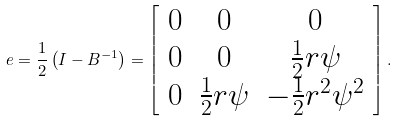<formula> <loc_0><loc_0><loc_500><loc_500>e = \frac { 1 } { 2 } \left ( I - B ^ { - 1 } \right ) = \left [ \begin{array} { c c c } 0 & 0 & 0 \\ 0 & 0 & \frac { 1 } { 2 } r \psi \\ 0 & \frac { 1 } { 2 } r \psi & - \frac { 1 } { 2 } r ^ { 2 } \psi ^ { 2 } \end{array} \right ] .</formula> 